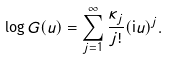Convert formula to latex. <formula><loc_0><loc_0><loc_500><loc_500>\log G ( u ) = \sum _ { j = 1 } ^ { \infty } \frac { \kappa _ { j } } { j ! } ( \mathrm i u ) ^ { j } .</formula> 